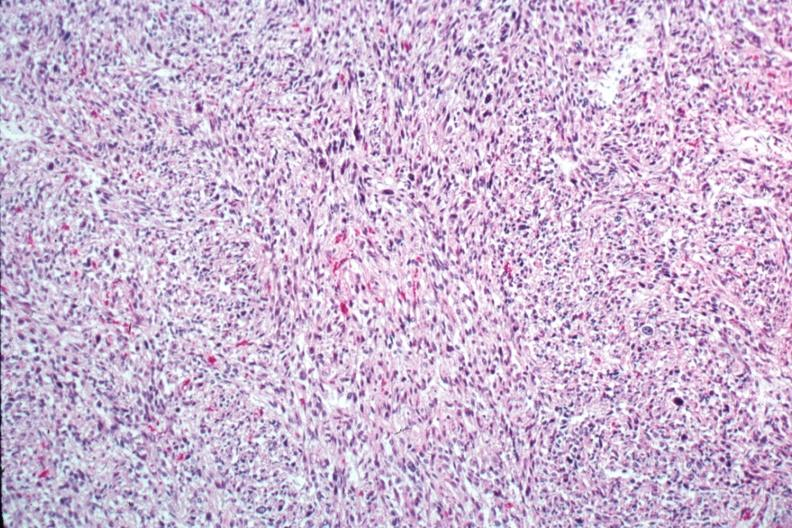how does this image show excellent photo of pleomorphic spindle cell tumor?
Answer the question using a single word or phrase. With storiform pattern 